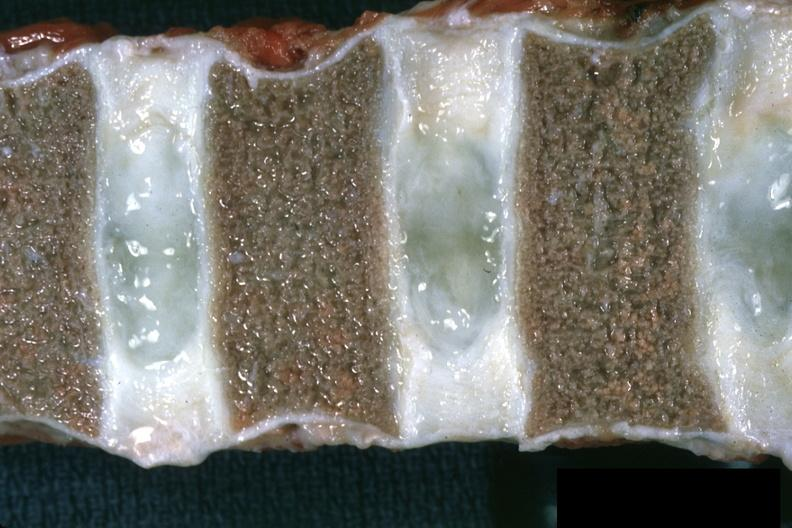what does this image show?
Answer the question using a single word or phrase. Close-up view well shown normal discs case of chronic myelogenous leukemia in a 14yo male vertebra are somewhat collapsed 